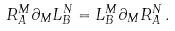Convert formula to latex. <formula><loc_0><loc_0><loc_500><loc_500>R ^ { M } _ { A } \partial _ { M } L ^ { N } _ { B } = L ^ { M } _ { B } \partial _ { M } R ^ { N } _ { A } \, .</formula> 